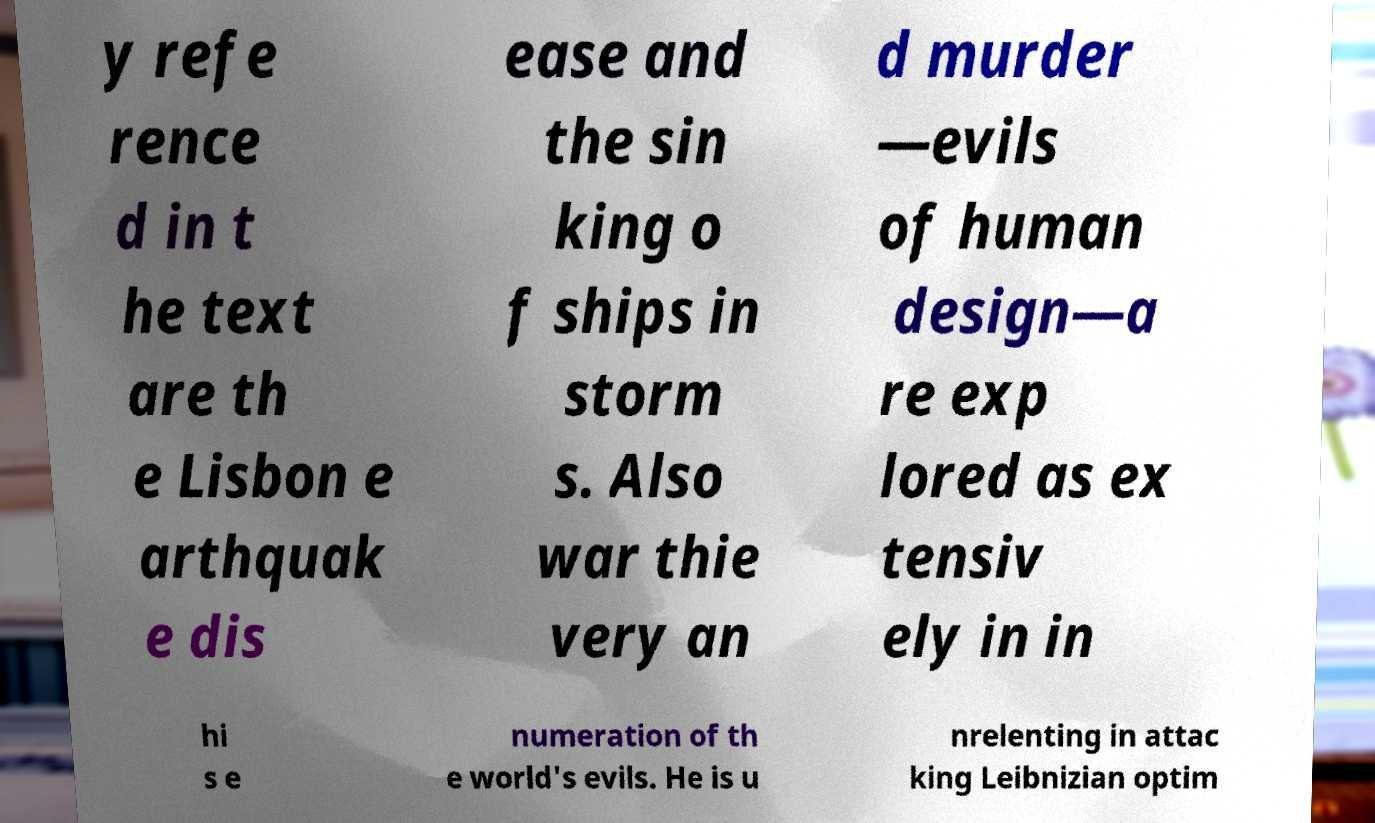Can you accurately transcribe the text from the provided image for me? y refe rence d in t he text are th e Lisbon e arthquak e dis ease and the sin king o f ships in storm s. Also war thie very an d murder —evils of human design—a re exp lored as ex tensiv ely in in hi s e numeration of th e world's evils. He is u nrelenting in attac king Leibnizian optim 